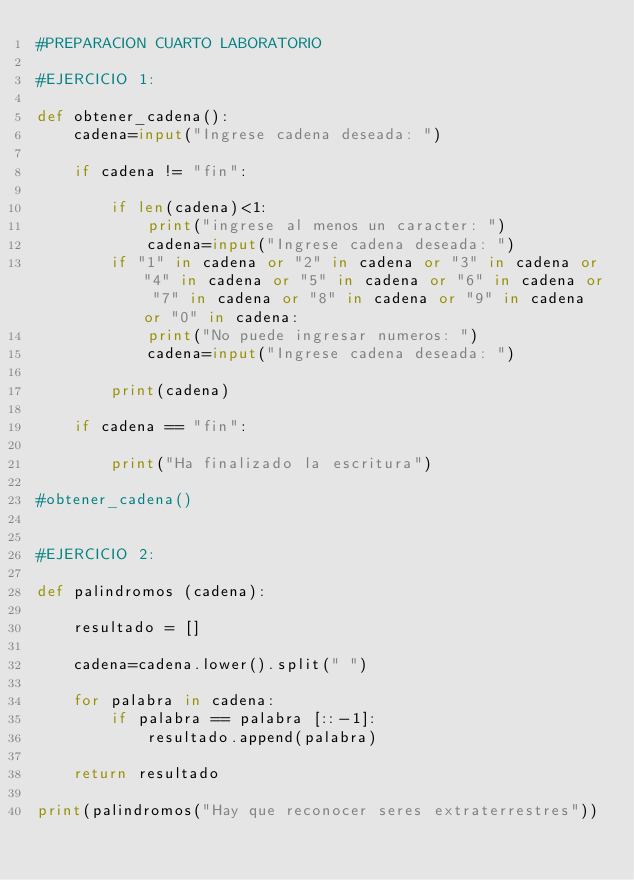Convert code to text. <code><loc_0><loc_0><loc_500><loc_500><_Python_>#PREPARACION CUARTO LABORATORIO

#EJERCICIO 1:

def obtener_cadena():
    cadena=input("Ingrese cadena deseada: ")

    if cadena != "fin":
        
        if len(cadena)<1:
            print("ingrese al menos un caracter: ")
            cadena=input("Ingrese cadena deseada: ")
        if "1" in cadena or "2" in cadena or "3" in cadena or "4" in cadena or "5" in cadena or "6" in cadena or "7" in cadena or "8" in cadena or "9" in cadena or "0" in cadena:
            print("No puede ingresar numeros: ")
            cadena=input("Ingrese cadena deseada: ")
            
        print(cadena)

    if cadena == "fin":

        print("Ha finalizado la escritura")    
       
#obtener_cadena()    


#EJERCICIO 2:

def palindromos (cadena):

    resultado = []

    cadena=cadena.lower().split(" ")

    for palabra in cadena:
        if palabra == palabra [::-1]:
            resultado.append(palabra)

    return resultado

print(palindromos("Hay que reconocer seres extraterrestres"))

    

    
</code> 